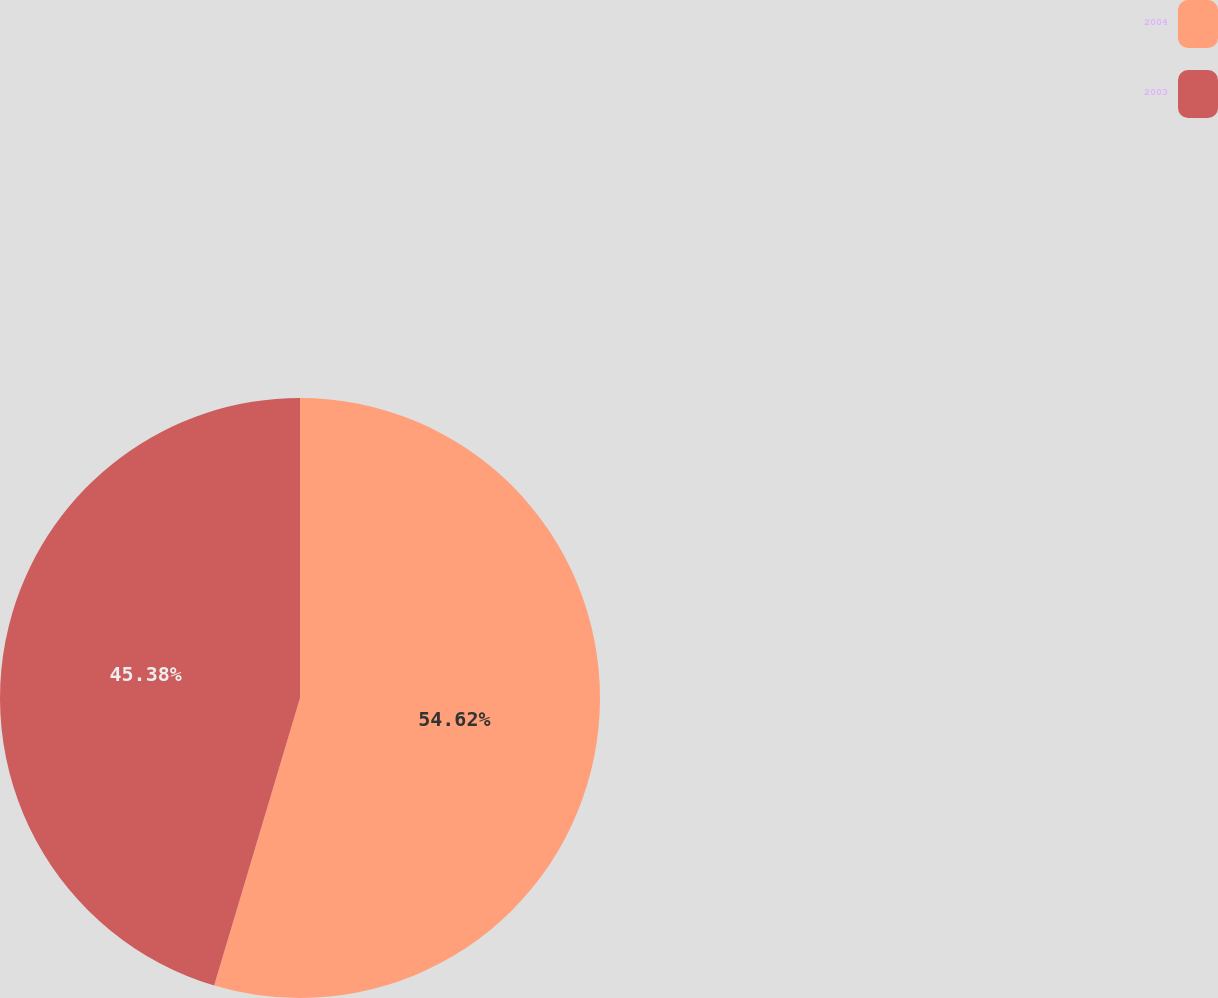Convert chart. <chart><loc_0><loc_0><loc_500><loc_500><pie_chart><fcel>2004<fcel>2003<nl><fcel>54.62%<fcel>45.38%<nl></chart> 